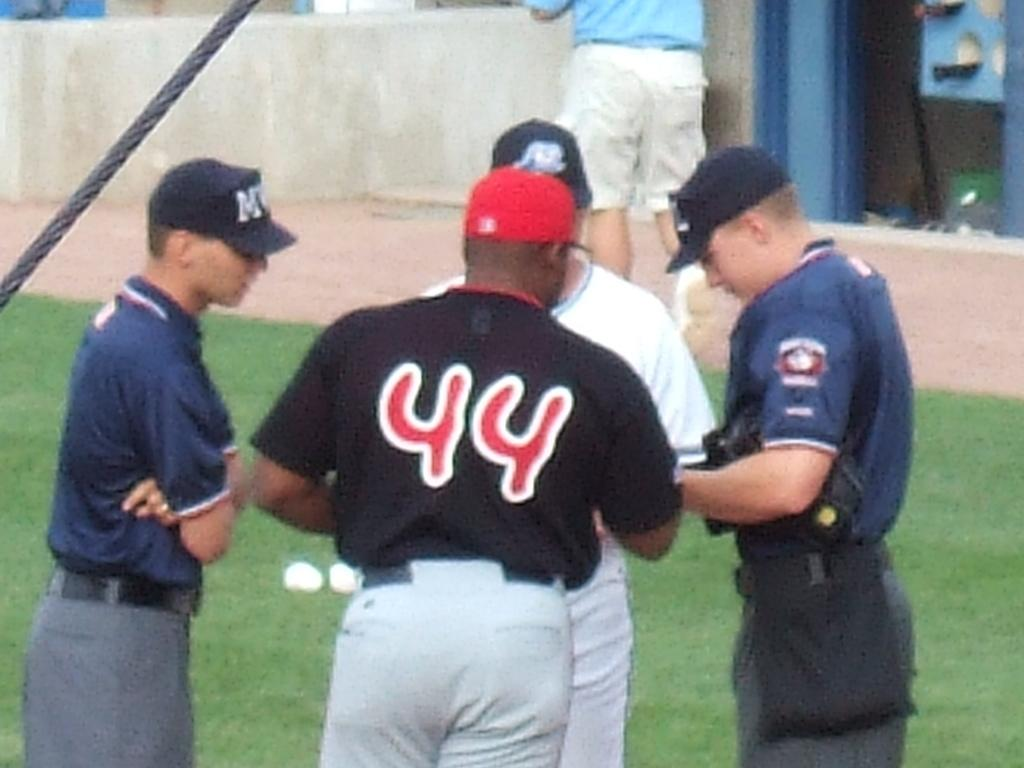<image>
Summarize the visual content of the image. Player number 44 is talking to some refs and players. 